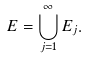Convert formula to latex. <formula><loc_0><loc_0><loc_500><loc_500>E = \bigcup _ { j = 1 } ^ { \infty } E _ { j } .</formula> 